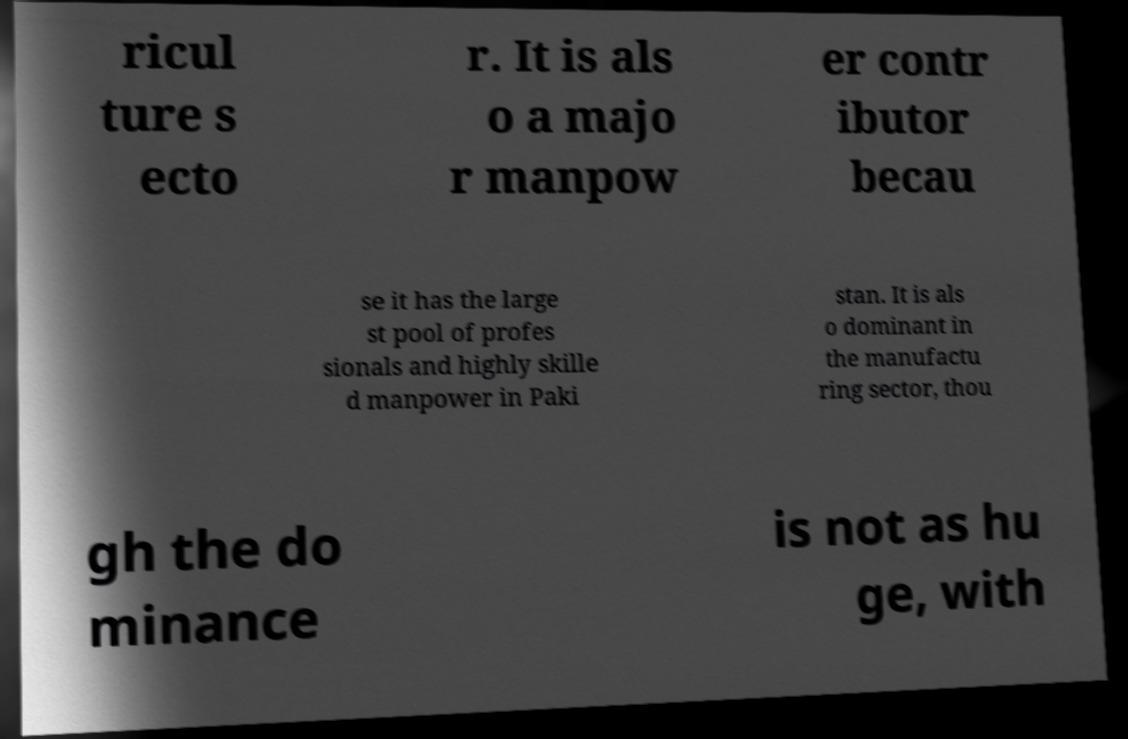Can you read and provide the text displayed in the image?This photo seems to have some interesting text. Can you extract and type it out for me? ricul ture s ecto r. It is als o a majo r manpow er contr ibutor becau se it has the large st pool of profes sionals and highly skille d manpower in Paki stan. It is als o dominant in the manufactu ring sector, thou gh the do minance is not as hu ge, with 